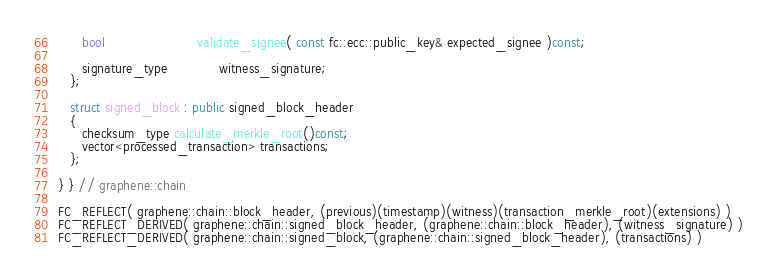Convert code to text. <code><loc_0><loc_0><loc_500><loc_500><_C++_>      bool                       validate_signee( const fc::ecc::public_key& expected_signee )const;

      signature_type             witness_signature;
   };

   struct signed_block : public signed_block_header
   {
      checksum_type calculate_merkle_root()const;
      vector<processed_transaction> transactions;
   };

} } // graphene::chain

FC_REFLECT( graphene::chain::block_header, (previous)(timestamp)(witness)(transaction_merkle_root)(extensions) )
FC_REFLECT_DERIVED( graphene::chain::signed_block_header, (graphene::chain::block_header), (witness_signature) )
FC_REFLECT_DERIVED( graphene::chain::signed_block, (graphene::chain::signed_block_header), (transactions) )
</code> 